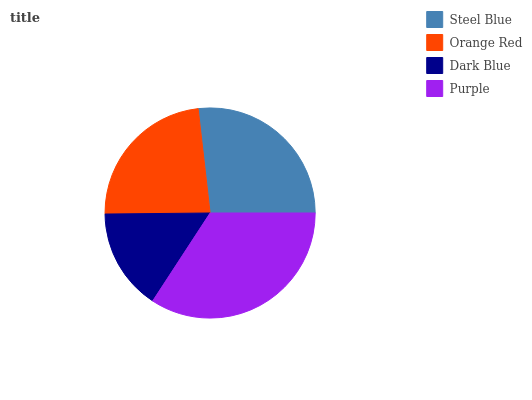Is Dark Blue the minimum?
Answer yes or no. Yes. Is Purple the maximum?
Answer yes or no. Yes. Is Orange Red the minimum?
Answer yes or no. No. Is Orange Red the maximum?
Answer yes or no. No. Is Steel Blue greater than Orange Red?
Answer yes or no. Yes. Is Orange Red less than Steel Blue?
Answer yes or no. Yes. Is Orange Red greater than Steel Blue?
Answer yes or no. No. Is Steel Blue less than Orange Red?
Answer yes or no. No. Is Steel Blue the high median?
Answer yes or no. Yes. Is Orange Red the low median?
Answer yes or no. Yes. Is Orange Red the high median?
Answer yes or no. No. Is Dark Blue the low median?
Answer yes or no. No. 